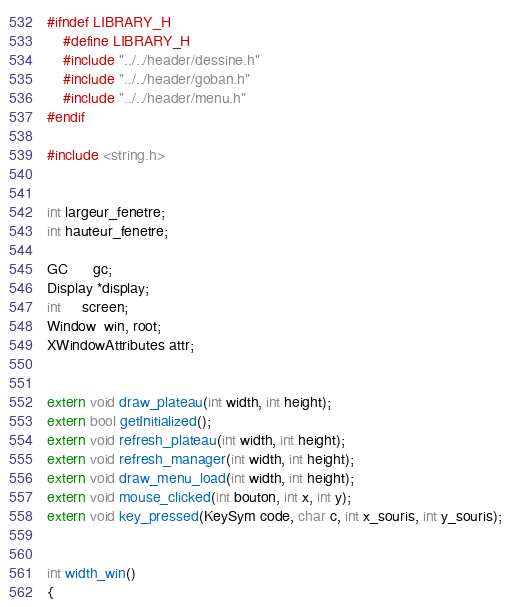Convert code to text. <code><loc_0><loc_0><loc_500><loc_500><_C_>#ifndef LIBRARY_H
	#define LIBRARY_H
	#include "../../header/dessine.h"
	#include "../../header/goban.h"
	#include "../../header/menu.h"
#endif

#include <string.h>


int largeur_fenetre;
int hauteur_fenetre;

GC      gc;
Display *display;
int     screen;
Window  win, root;
XWindowAttributes attr;


extern void draw_plateau(int width, int height);
extern bool getInitialized();
extern void refresh_plateau(int width, int height);
extern void refresh_manager(int width, int height);
extern void draw_menu_load(int width, int height);
extern void mouse_clicked(int bouton, int x, int y);
extern void key_pressed(KeySym code, char c, int x_souris, int y_souris);


int width_win()
{</code> 